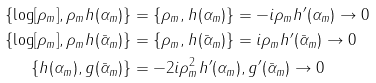<formula> <loc_0><loc_0><loc_500><loc_500>\{ \log [ \rho _ { m } ] , \rho _ { m } h ( \alpha _ { m } ) \} & = \{ \rho _ { m } , h ( \alpha _ { m } ) \} = - i \rho _ { m } h ^ { \prime } ( \alpha _ { m } ) \to 0 \\ \{ \log [ \rho _ { m } ] , \rho _ { m } h ( \bar { \alpha } _ { m } ) \} & = \{ \rho _ { m } , h ( \bar { \alpha } _ { m } ) \} = i \rho _ { m } h ^ { \prime } ( \bar { \alpha } _ { m } ) \to 0 \\ \{ h ( \alpha _ { m } ) , g ( \bar { \alpha } _ { m } ) \} & = - 2 i \rho _ { m } ^ { 2 } h ^ { \prime } ( \alpha _ { m } ) , g ^ { \prime } ( \bar { \alpha } _ { m } ) \to 0</formula> 